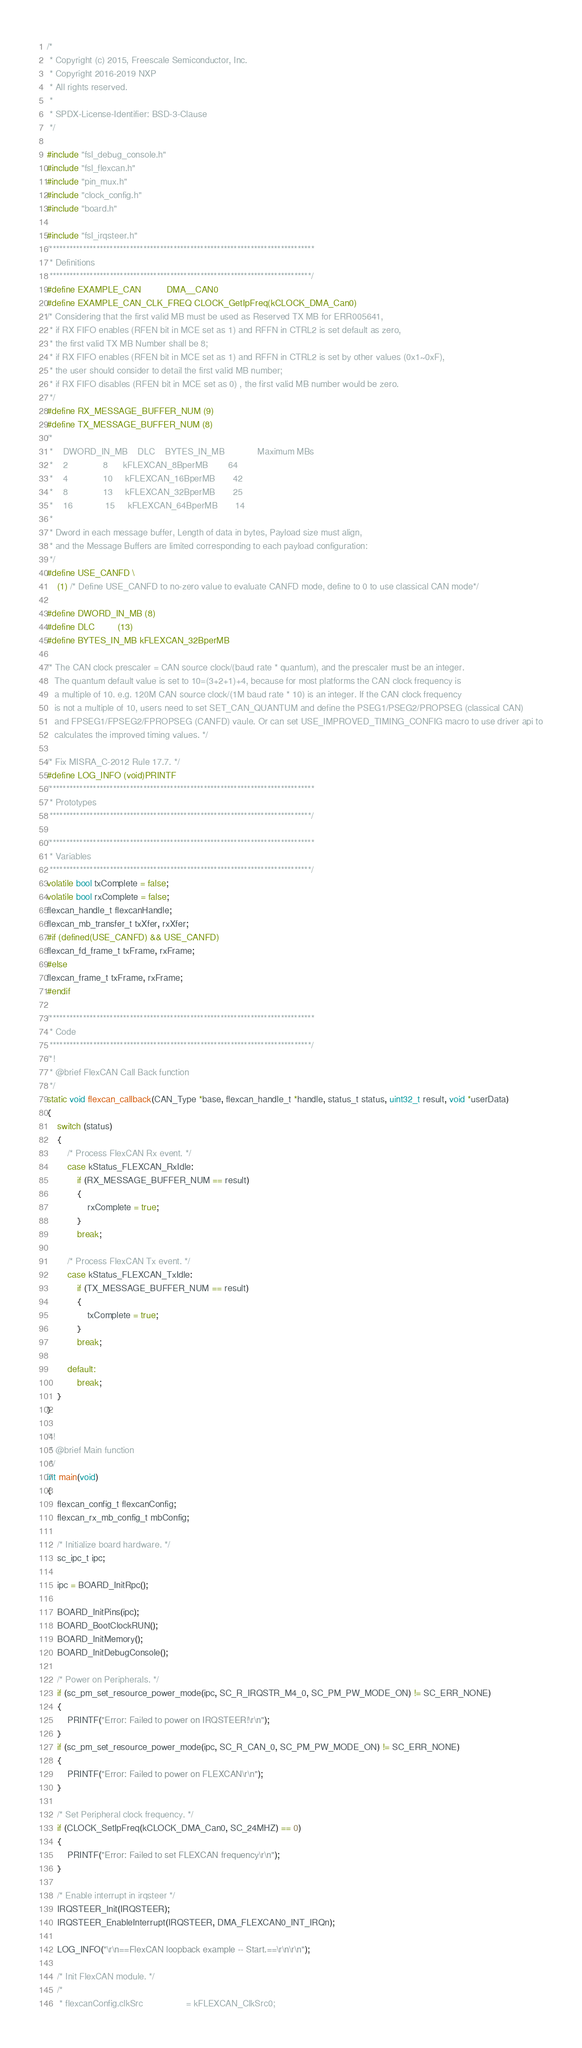Convert code to text. <code><loc_0><loc_0><loc_500><loc_500><_C_>/*
 * Copyright (c) 2015, Freescale Semiconductor, Inc.
 * Copyright 2016-2019 NXP
 * All rights reserved.
 *
 * SPDX-License-Identifier: BSD-3-Clause
 */

#include "fsl_debug_console.h"
#include "fsl_flexcan.h"
#include "pin_mux.h"
#include "clock_config.h"
#include "board.h"

#include "fsl_irqsteer.h"
/*******************************************************************************
 * Definitions
 ******************************************************************************/
#define EXAMPLE_CAN          DMA__CAN0
#define EXAMPLE_CAN_CLK_FREQ CLOCK_GetIpFreq(kCLOCK_DMA_Can0)
/* Considering that the first valid MB must be used as Reserved TX MB for ERR005641,
 * if RX FIFO enables (RFEN bit in MCE set as 1) and RFFN in CTRL2 is set default as zero,
 * the first valid TX MB Number shall be 8;
 * if RX FIFO enables (RFEN bit in MCE set as 1) and RFFN in CTRL2 is set by other values (0x1~0xF),
 * the user should consider to detail the first valid MB number;
 * if RX FIFO disables (RFEN bit in MCE set as 0) , the first valid MB number would be zero.
 */
#define RX_MESSAGE_BUFFER_NUM (9)
#define TX_MESSAGE_BUFFER_NUM (8)
/*
 *    DWORD_IN_MB    DLC    BYTES_IN_MB             Maximum MBs
 *    2              8      kFLEXCAN_8BperMB        64
 *    4              10     kFLEXCAN_16BperMB       42
 *    8              13     kFLEXCAN_32BperMB       25
 *    16             15     kFLEXCAN_64BperMB       14
 *
 * Dword in each message buffer, Length of data in bytes, Payload size must align,
 * and the Message Buffers are limited corresponding to each payload configuration:
 */
#define USE_CANFD \
    (1) /* Define USE_CANFD to no-zero value to evaluate CANFD mode, define to 0 to use classical CAN mode*/

#define DWORD_IN_MB (8)
#define DLC         (13)
#define BYTES_IN_MB kFLEXCAN_32BperMB

/* The CAN clock prescaler = CAN source clock/(baud rate * quantum), and the prescaler must be an integer.
   The quantum default value is set to 10=(3+2+1)+4, because for most platforms the CAN clock frequency is
   a multiple of 10. e.g. 120M CAN source clock/(1M baud rate * 10) is an integer. If the CAN clock frequency
   is not a multiple of 10, users need to set SET_CAN_QUANTUM and define the PSEG1/PSEG2/PROPSEG (classical CAN)
   and FPSEG1/FPSEG2/FPROPSEG (CANFD) vaule. Or can set USE_IMPROVED_TIMING_CONFIG macro to use driver api to
   calculates the improved timing values. */

/* Fix MISRA_C-2012 Rule 17.7. */
#define LOG_INFO (void)PRINTF
/*******************************************************************************
 * Prototypes
 ******************************************************************************/

/*******************************************************************************
 * Variables
 ******************************************************************************/
volatile bool txComplete = false;
volatile bool rxComplete = false;
flexcan_handle_t flexcanHandle;
flexcan_mb_transfer_t txXfer, rxXfer;
#if (defined(USE_CANFD) && USE_CANFD)
flexcan_fd_frame_t txFrame, rxFrame;
#else
flexcan_frame_t txFrame, rxFrame;
#endif

/*******************************************************************************
 * Code
 ******************************************************************************/
/*!
 * @brief FlexCAN Call Back function
 */
static void flexcan_callback(CAN_Type *base, flexcan_handle_t *handle, status_t status, uint32_t result, void *userData)
{
    switch (status)
    {
        /* Process FlexCAN Rx event. */
        case kStatus_FLEXCAN_RxIdle:
            if (RX_MESSAGE_BUFFER_NUM == result)
            {
                rxComplete = true;
            }
            break;

        /* Process FlexCAN Tx event. */
        case kStatus_FLEXCAN_TxIdle:
            if (TX_MESSAGE_BUFFER_NUM == result)
            {
                txComplete = true;
            }
            break;

        default:
            break;
    }
}

/*!
 * @brief Main function
 */
int main(void)
{
    flexcan_config_t flexcanConfig;
    flexcan_rx_mb_config_t mbConfig;

    /* Initialize board hardware. */
    sc_ipc_t ipc;

    ipc = BOARD_InitRpc();

    BOARD_InitPins(ipc);
    BOARD_BootClockRUN();
    BOARD_InitMemory();
    BOARD_InitDebugConsole();

    /* Power on Peripherals. */
    if (sc_pm_set_resource_power_mode(ipc, SC_R_IRQSTR_M4_0, SC_PM_PW_MODE_ON) != SC_ERR_NONE)
    {
        PRINTF("Error: Failed to power on IRQSTEER!\r\n");
    }
    if (sc_pm_set_resource_power_mode(ipc, SC_R_CAN_0, SC_PM_PW_MODE_ON) != SC_ERR_NONE)
    {
        PRINTF("Error: Failed to power on FLEXCAN\r\n");
    }

    /* Set Peripheral clock frequency. */
    if (CLOCK_SetIpFreq(kCLOCK_DMA_Can0, SC_24MHZ) == 0)
    {
        PRINTF("Error: Failed to set FLEXCAN frequency\r\n");
    }

    /* Enable interrupt in irqsteer */
    IRQSTEER_Init(IRQSTEER);
    IRQSTEER_EnableInterrupt(IRQSTEER, DMA_FLEXCAN0_INT_IRQn);

    LOG_INFO("\r\n==FlexCAN loopback example -- Start.==\r\n\r\n");

    /* Init FlexCAN module. */
    /*
     * flexcanConfig.clkSrc                 = kFLEXCAN_ClkSrc0;</code> 